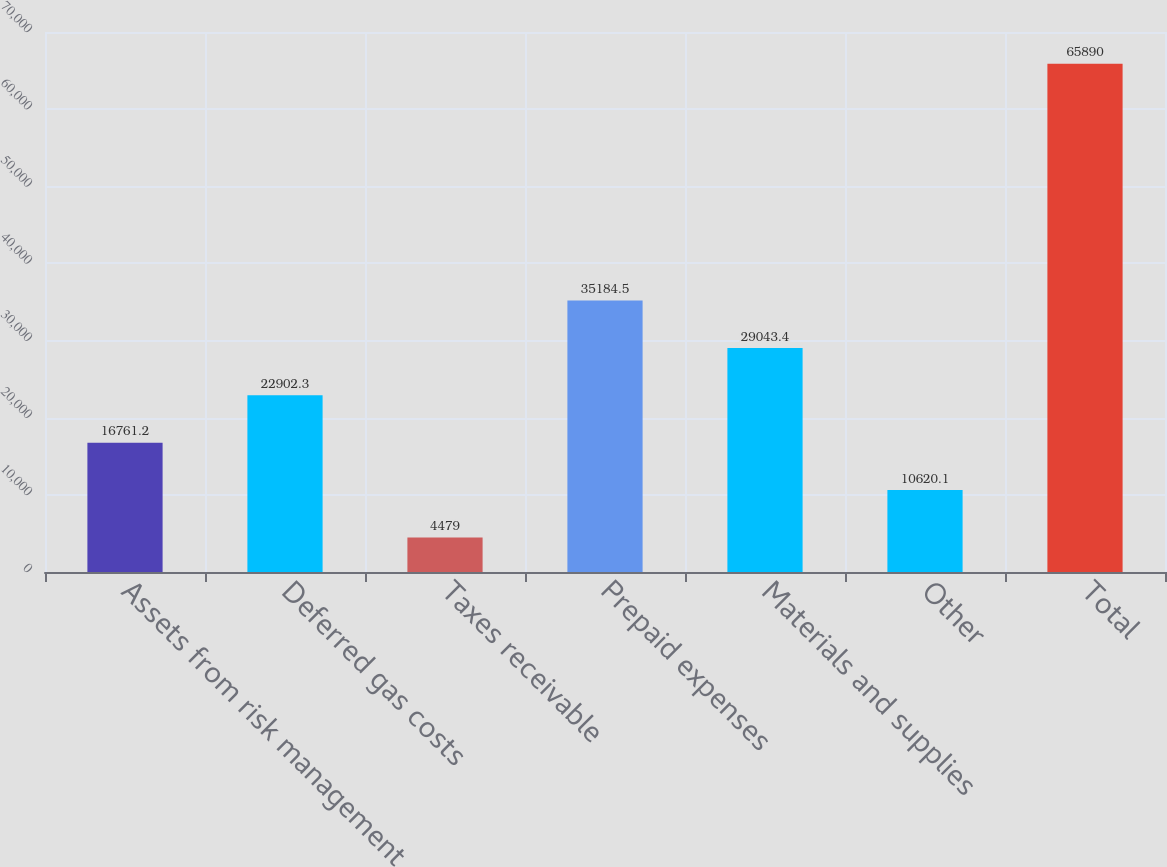Convert chart to OTSL. <chart><loc_0><loc_0><loc_500><loc_500><bar_chart><fcel>Assets from risk management<fcel>Deferred gas costs<fcel>Taxes receivable<fcel>Prepaid expenses<fcel>Materials and supplies<fcel>Other<fcel>Total<nl><fcel>16761.2<fcel>22902.3<fcel>4479<fcel>35184.5<fcel>29043.4<fcel>10620.1<fcel>65890<nl></chart> 